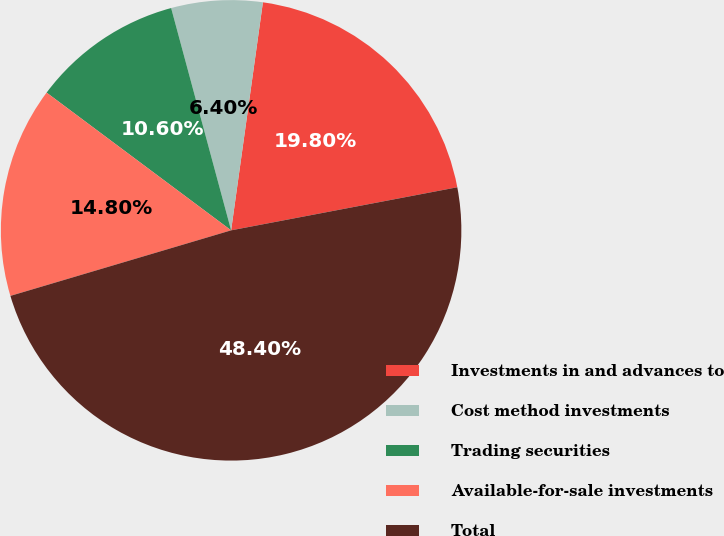<chart> <loc_0><loc_0><loc_500><loc_500><pie_chart><fcel>Investments in and advances to<fcel>Cost method investments<fcel>Trading securities<fcel>Available-for-sale investments<fcel>Total<nl><fcel>19.8%<fcel>6.4%<fcel>10.6%<fcel>14.8%<fcel>48.4%<nl></chart> 